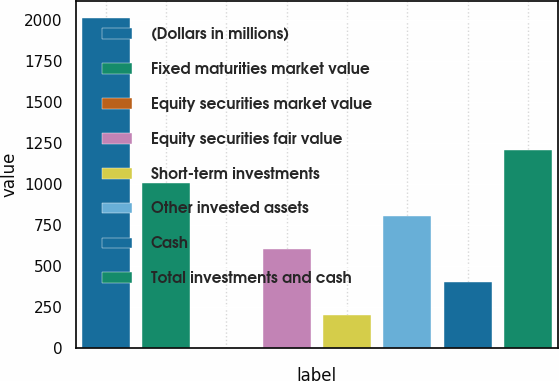Convert chart to OTSL. <chart><loc_0><loc_0><loc_500><loc_500><bar_chart><fcel>(Dollars in millions)<fcel>Fixed maturities market value<fcel>Equity securities market value<fcel>Equity securities fair value<fcel>Short-term investments<fcel>Other invested assets<fcel>Cash<fcel>Total investments and cash<nl><fcel>2016<fcel>1008.35<fcel>0.7<fcel>605.29<fcel>202.23<fcel>806.82<fcel>403.76<fcel>1209.88<nl></chart> 